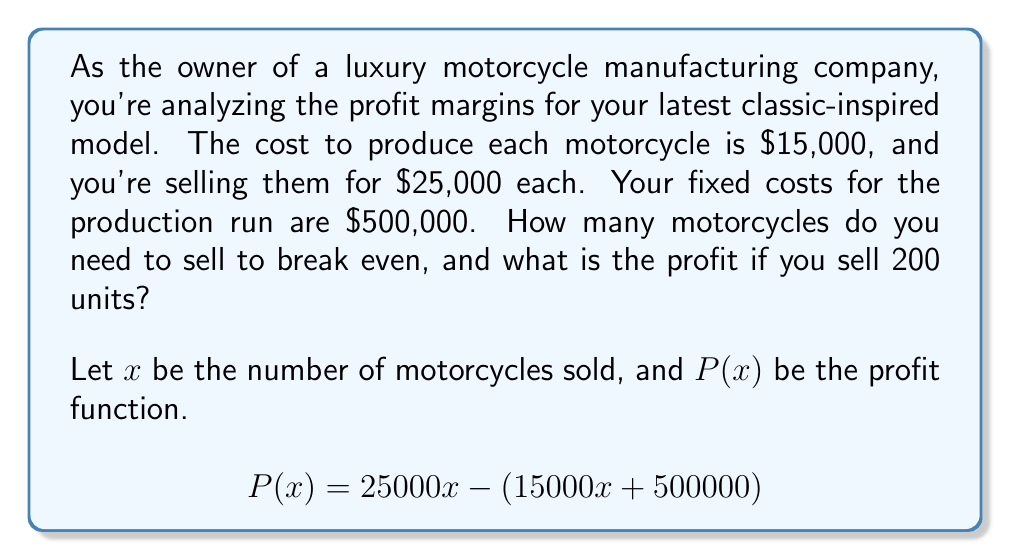Teach me how to tackle this problem. 1. Set up the profit function:
   $$P(x) = 25000x - (15000x + 500000)$$

2. Simplify the equation:
   $$P(x) = 25000x - 15000x - 500000$$
   $$P(x) = 10000x - 500000$$

3. To find the break-even point, set $P(x) = 0$:
   $$0 = 10000x - 500000$$
   $$500000 = 10000x$$
   $$x = 50$$

4. To calculate the profit for 200 units, substitute $x = 200$ into the profit function:
   $$P(200) = 10000(200) - 500000$$
   $$P(200) = 2000000 - 500000$$
   $$P(200) = 1500000$$
Answer: Break-even point: 50 motorcycles; Profit for 200 units: $1,500,000 